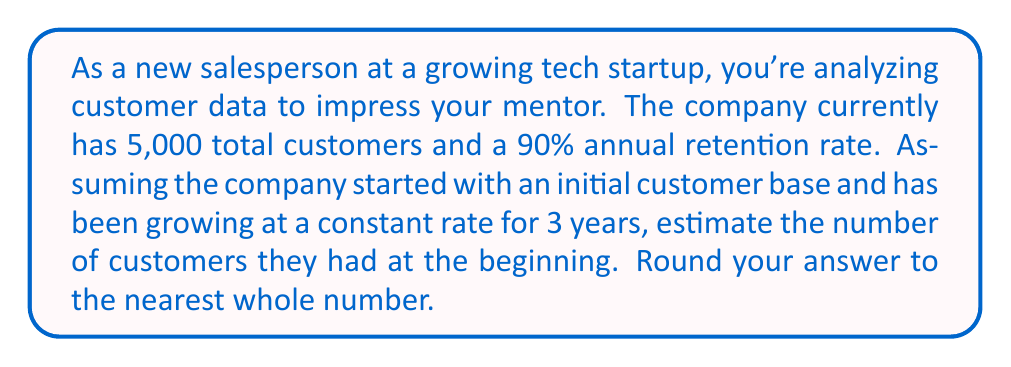Can you solve this math problem? Let's approach this step-by-step:

1) Let $x$ be the initial number of customers.

2) With a 90% retention rate, the company keeps 90% of its customers each year and loses 10%.

3) After 3 years, the initial customers remaining would be:
   $x \cdot (0.90)^3$

4) The total customers after 3 years is 5,000. This includes the remaining initial customers plus new customers gained each year.

5) We can represent this as an equation:
   $x \cdot (0.90)^3 + \text{new customers} = 5000$

6) We don't know the exact number of new customers gained each year, but we know it's a constant rate. Let's call this yearly gain $y$.

7) After 3 years, the new customers would be:
   $y + y \cdot 0.90 + y \cdot (0.90)^2$

8) Now our equation looks like this:
   $x \cdot (0.90)^3 + y + y \cdot 0.90 + y \cdot (0.90)^2 = 5000$

9) Simplify:
   $0.729x + 2.71y = 5000$

10) We have two unknowns and only one equation. To solve this inverse problem, we need to make an assumption. Let's assume that the yearly gain ($y$) is approximately equal to 10% of the initial customer base ($x$).

11) This gives us: $y = 0.1x$

12) Substitute this into our equation:
    $0.729x + 2.71(0.1x) = 5000$
    $0.729x + 0.271x = 5000$
    $x = 5000 / 1 = 5000$

13) Round to the nearest whole number: 5000
Answer: 5000 customers 